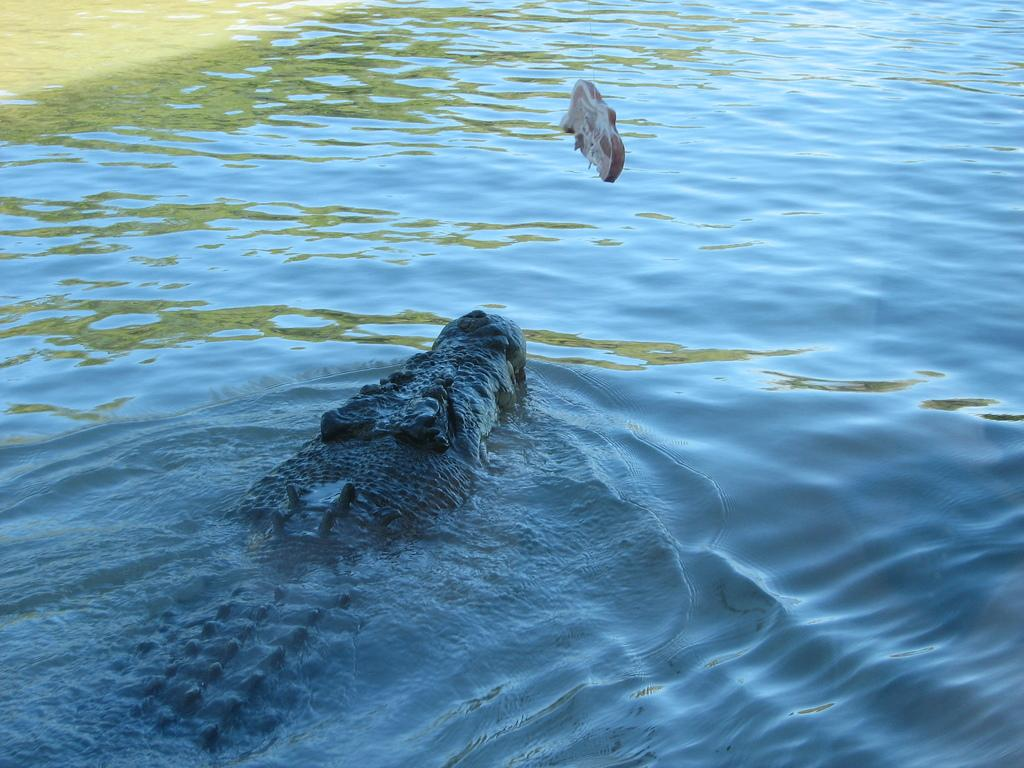What animal is present in the image? There is a crocodile in the image. Can you describe the environment in the image? There is an object in the water in the image. What attempts are being made to cure the disease in the image? There is no mention of a disease or attempts to cure it in the image. 